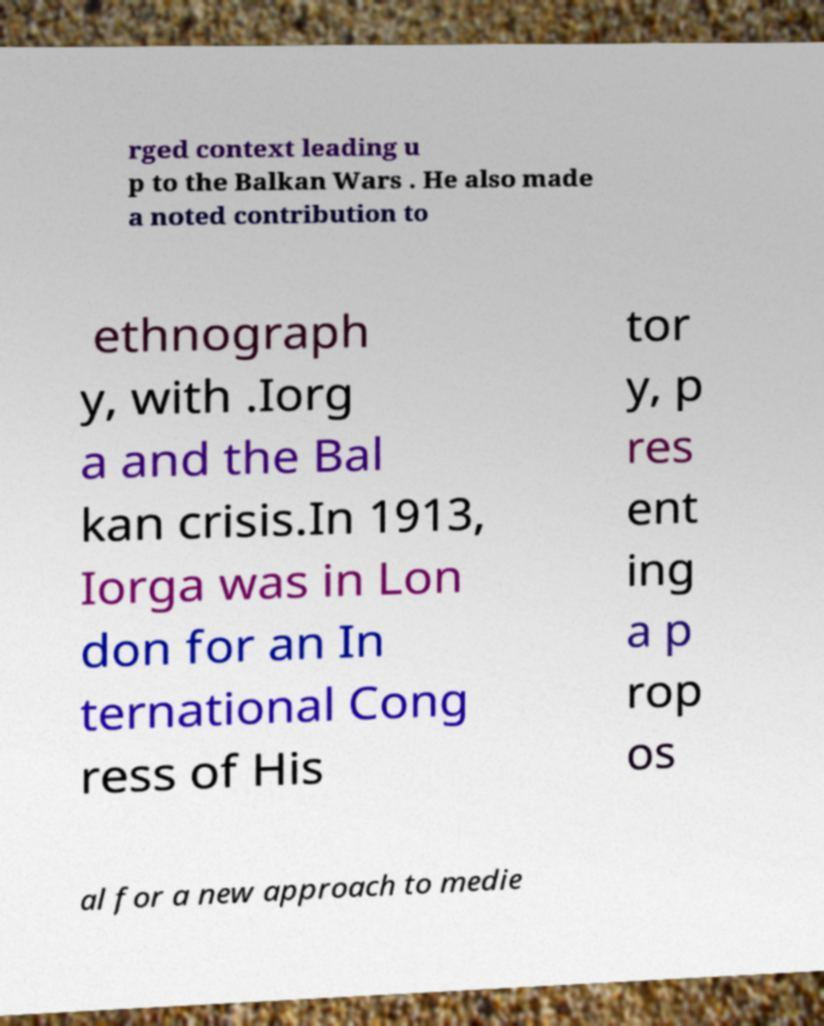Please read and relay the text visible in this image. What does it say? rged context leading u p to the Balkan Wars . He also made a noted contribution to ethnograph y, with .Iorg a and the Bal kan crisis.In 1913, Iorga was in Lon don for an In ternational Cong ress of His tor y, p res ent ing a p rop os al for a new approach to medie 